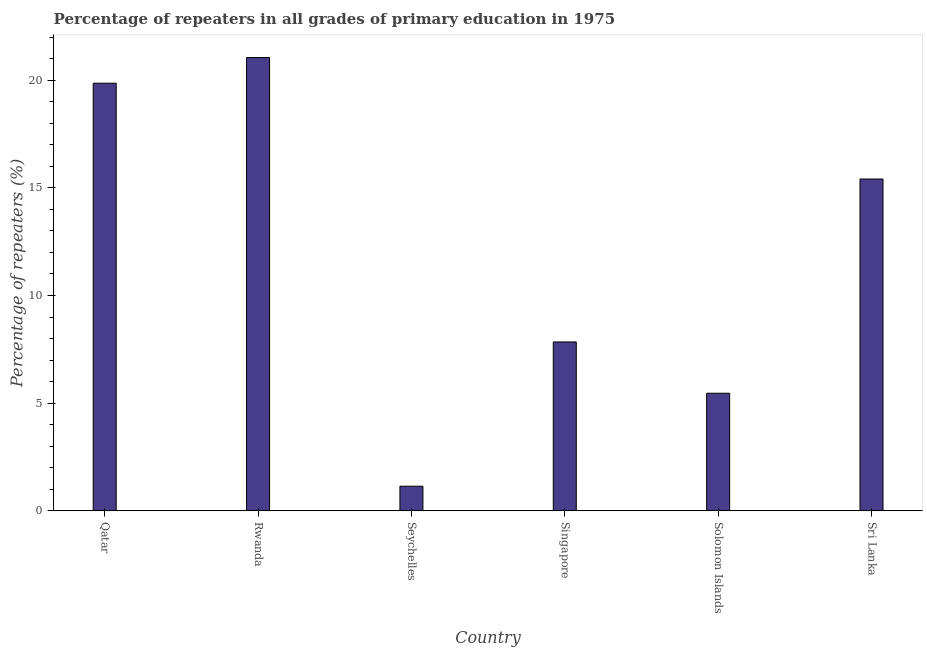Does the graph contain any zero values?
Make the answer very short. No. What is the title of the graph?
Provide a succinct answer. Percentage of repeaters in all grades of primary education in 1975. What is the label or title of the Y-axis?
Your response must be concise. Percentage of repeaters (%). What is the percentage of repeaters in primary education in Seychelles?
Provide a succinct answer. 1.14. Across all countries, what is the maximum percentage of repeaters in primary education?
Your answer should be compact. 21.05. Across all countries, what is the minimum percentage of repeaters in primary education?
Ensure brevity in your answer.  1.14. In which country was the percentage of repeaters in primary education maximum?
Offer a very short reply. Rwanda. In which country was the percentage of repeaters in primary education minimum?
Offer a terse response. Seychelles. What is the sum of the percentage of repeaters in primary education?
Keep it short and to the point. 70.77. What is the difference between the percentage of repeaters in primary education in Singapore and Solomon Islands?
Your response must be concise. 2.38. What is the average percentage of repeaters in primary education per country?
Make the answer very short. 11.79. What is the median percentage of repeaters in primary education?
Provide a succinct answer. 11.63. What is the ratio of the percentage of repeaters in primary education in Qatar to that in Seychelles?
Give a very brief answer. 17.37. What is the difference between the highest and the second highest percentage of repeaters in primary education?
Offer a very short reply. 1.19. What is the difference between the highest and the lowest percentage of repeaters in primary education?
Make the answer very short. 19.91. How many countries are there in the graph?
Provide a succinct answer. 6. What is the difference between two consecutive major ticks on the Y-axis?
Provide a short and direct response. 5. What is the Percentage of repeaters (%) of Qatar?
Keep it short and to the point. 19.86. What is the Percentage of repeaters (%) in Rwanda?
Your answer should be very brief. 21.05. What is the Percentage of repeaters (%) in Seychelles?
Give a very brief answer. 1.14. What is the Percentage of repeaters (%) of Singapore?
Provide a succinct answer. 7.84. What is the Percentage of repeaters (%) of Solomon Islands?
Ensure brevity in your answer.  5.46. What is the Percentage of repeaters (%) in Sri Lanka?
Your response must be concise. 15.41. What is the difference between the Percentage of repeaters (%) in Qatar and Rwanda?
Ensure brevity in your answer.  -1.19. What is the difference between the Percentage of repeaters (%) in Qatar and Seychelles?
Keep it short and to the point. 18.72. What is the difference between the Percentage of repeaters (%) in Qatar and Singapore?
Provide a succinct answer. 12.02. What is the difference between the Percentage of repeaters (%) in Qatar and Solomon Islands?
Offer a very short reply. 14.4. What is the difference between the Percentage of repeaters (%) in Qatar and Sri Lanka?
Keep it short and to the point. 4.45. What is the difference between the Percentage of repeaters (%) in Rwanda and Seychelles?
Your answer should be compact. 19.91. What is the difference between the Percentage of repeaters (%) in Rwanda and Singapore?
Your response must be concise. 13.21. What is the difference between the Percentage of repeaters (%) in Rwanda and Solomon Islands?
Provide a succinct answer. 15.59. What is the difference between the Percentage of repeaters (%) in Rwanda and Sri Lanka?
Your response must be concise. 5.64. What is the difference between the Percentage of repeaters (%) in Seychelles and Singapore?
Provide a succinct answer. -6.7. What is the difference between the Percentage of repeaters (%) in Seychelles and Solomon Islands?
Provide a succinct answer. -4.32. What is the difference between the Percentage of repeaters (%) in Seychelles and Sri Lanka?
Your answer should be compact. -14.27. What is the difference between the Percentage of repeaters (%) in Singapore and Solomon Islands?
Give a very brief answer. 2.38. What is the difference between the Percentage of repeaters (%) in Singapore and Sri Lanka?
Provide a short and direct response. -7.57. What is the difference between the Percentage of repeaters (%) in Solomon Islands and Sri Lanka?
Give a very brief answer. -9.95. What is the ratio of the Percentage of repeaters (%) in Qatar to that in Rwanda?
Keep it short and to the point. 0.94. What is the ratio of the Percentage of repeaters (%) in Qatar to that in Seychelles?
Your response must be concise. 17.37. What is the ratio of the Percentage of repeaters (%) in Qatar to that in Singapore?
Offer a very short reply. 2.53. What is the ratio of the Percentage of repeaters (%) in Qatar to that in Solomon Islands?
Make the answer very short. 3.64. What is the ratio of the Percentage of repeaters (%) in Qatar to that in Sri Lanka?
Your answer should be very brief. 1.29. What is the ratio of the Percentage of repeaters (%) in Rwanda to that in Seychelles?
Give a very brief answer. 18.41. What is the ratio of the Percentage of repeaters (%) in Rwanda to that in Singapore?
Provide a succinct answer. 2.68. What is the ratio of the Percentage of repeaters (%) in Rwanda to that in Solomon Islands?
Make the answer very short. 3.85. What is the ratio of the Percentage of repeaters (%) in Rwanda to that in Sri Lanka?
Keep it short and to the point. 1.37. What is the ratio of the Percentage of repeaters (%) in Seychelles to that in Singapore?
Offer a very short reply. 0.15. What is the ratio of the Percentage of repeaters (%) in Seychelles to that in Solomon Islands?
Ensure brevity in your answer.  0.21. What is the ratio of the Percentage of repeaters (%) in Seychelles to that in Sri Lanka?
Provide a short and direct response. 0.07. What is the ratio of the Percentage of repeaters (%) in Singapore to that in Solomon Islands?
Offer a very short reply. 1.44. What is the ratio of the Percentage of repeaters (%) in Singapore to that in Sri Lanka?
Provide a short and direct response. 0.51. What is the ratio of the Percentage of repeaters (%) in Solomon Islands to that in Sri Lanka?
Offer a very short reply. 0.35. 